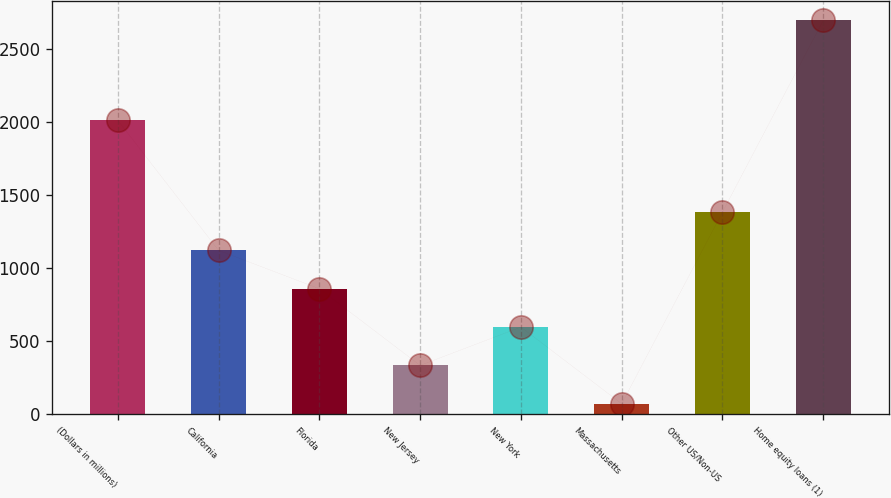Convert chart. <chart><loc_0><loc_0><loc_500><loc_500><bar_chart><fcel>(Dollars in millions)<fcel>California<fcel>Florida<fcel>New Jersey<fcel>New York<fcel>Massachusetts<fcel>Other US/Non-US<fcel>Home equity loans (1)<nl><fcel>2010<fcel>1120.2<fcel>857.9<fcel>333.3<fcel>595.6<fcel>71<fcel>1382.5<fcel>2694<nl></chart> 